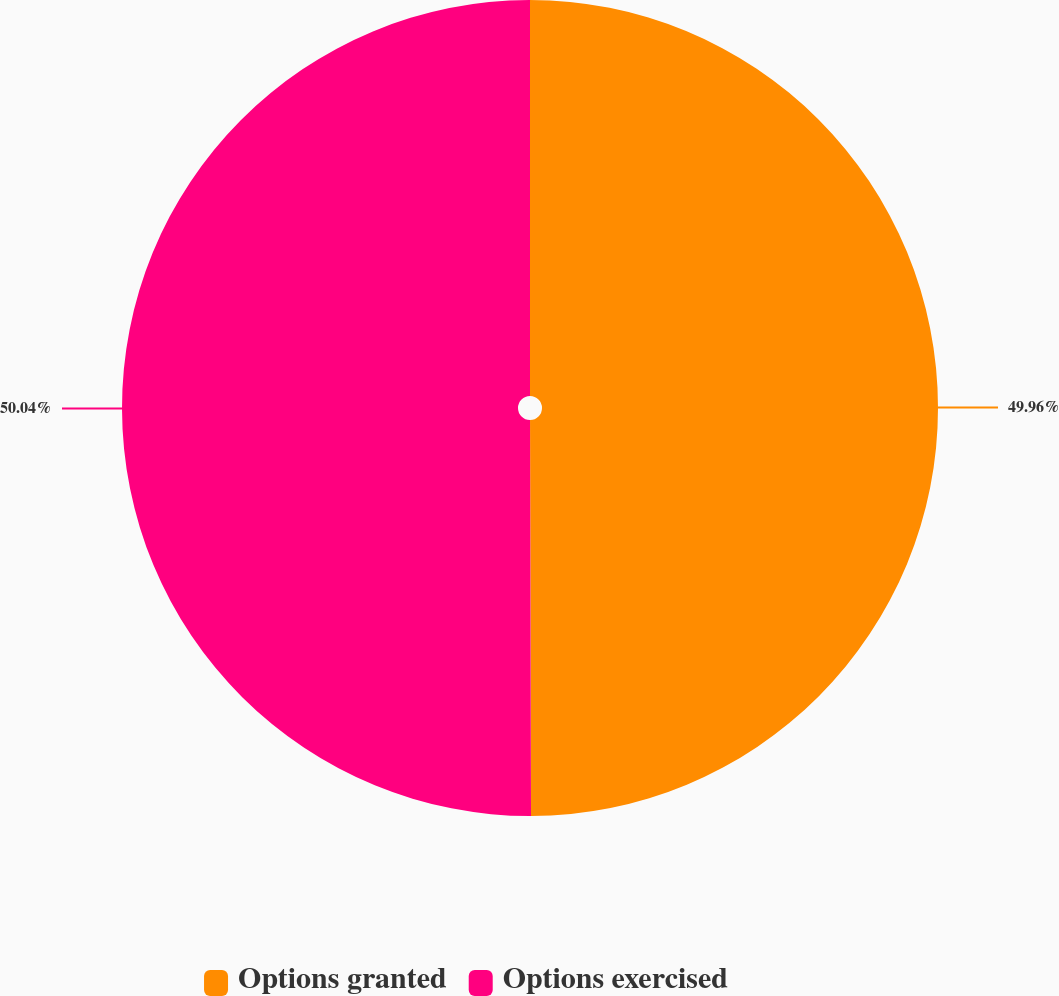Convert chart to OTSL. <chart><loc_0><loc_0><loc_500><loc_500><pie_chart><fcel>Options granted<fcel>Options exercised<nl><fcel>49.96%<fcel>50.04%<nl></chart> 